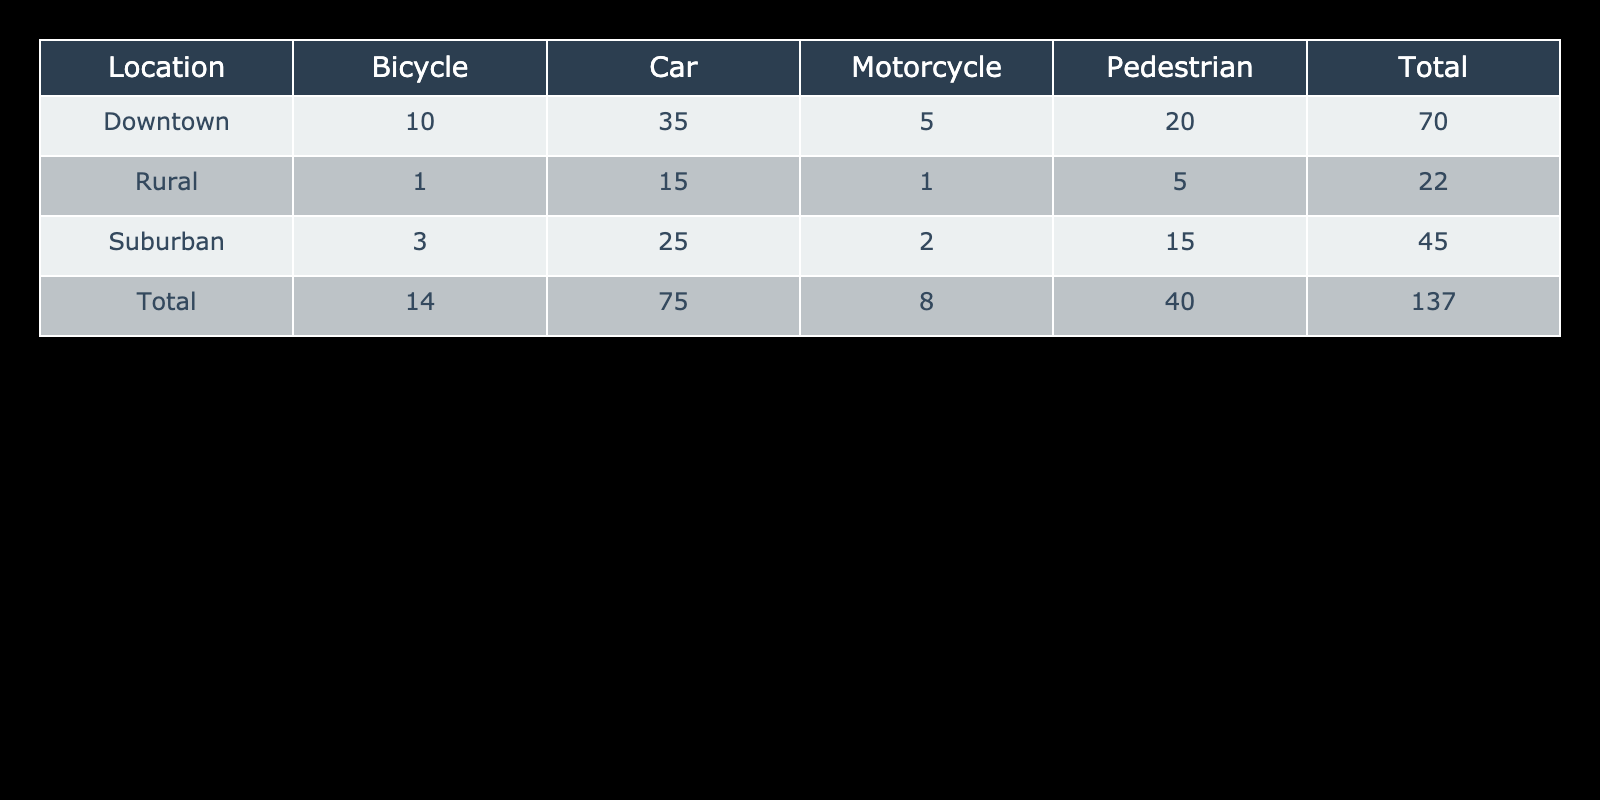What is the total number of accidents in Downtown? To find the total number of accidents in Downtown, I look at the "Total" column for the Downtown row in the table. The sum of accidents in Downtown is 35 (Car) + 10 (Bicycle) + 5 (Motorcycle) + 20 (Pedestrian) = 70.
Answer: 70 Which vehicle type had the highest accident count in the Suburban area? In the Suburban area, I compare the accident counts for each vehicle type: 25 (Car), 3 (Bicycle), 2 (Motorcycle), and 15 (Pedestrian). The highest count is 25 for Car.
Answer: Car How many accidents involved Pedestrians across all locations? To find the total number of accidents involving Pedestrians, I add the values from the Pedestrian row for all locations: 20 (Downtown) + 15 (Suburban) + 5 (Rural) = 40.
Answer: 40 Is it true that there were more Bicycle accidents in Rural areas than in Downtown? I compare the accident counts for Bicycle: 1 in Rural and 10 in Downtown. Since 10 is greater than 1, the statement is false.
Answer: No What is the average number of Motorcycle accidents across all locations? To find the average, I first sum the Motorcycle accident counts: 5 (Downtown) + 2 (Suburban) + 1 (Rural) = 8. There are 3 locations, so I divide 8 by 3, giving an average of 8/3, approximately 2.67.
Answer: 2.67 